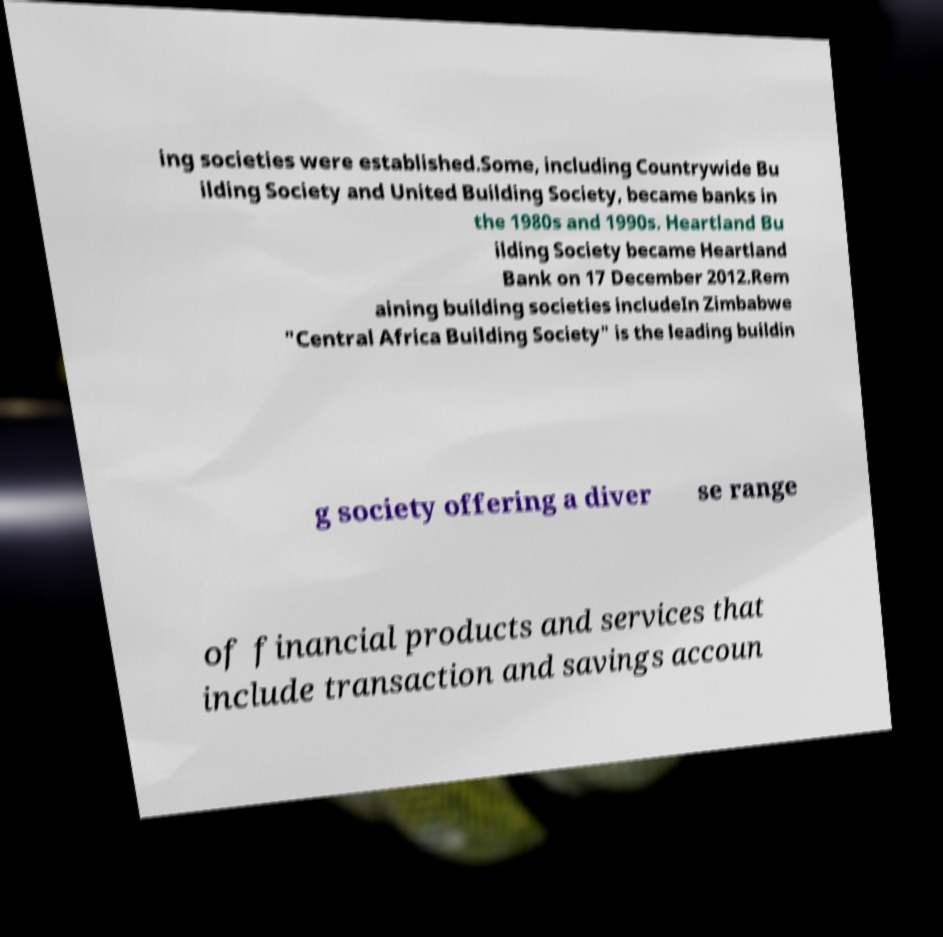Could you assist in decoding the text presented in this image and type it out clearly? ing societies were established.Some, including Countrywide Bu ilding Society and United Building Society, became banks in the 1980s and 1990s. Heartland Bu ilding Society became Heartland Bank on 17 December 2012.Rem aining building societies includeIn Zimbabwe "Central Africa Building Society" is the leading buildin g society offering a diver se range of financial products and services that include transaction and savings accoun 